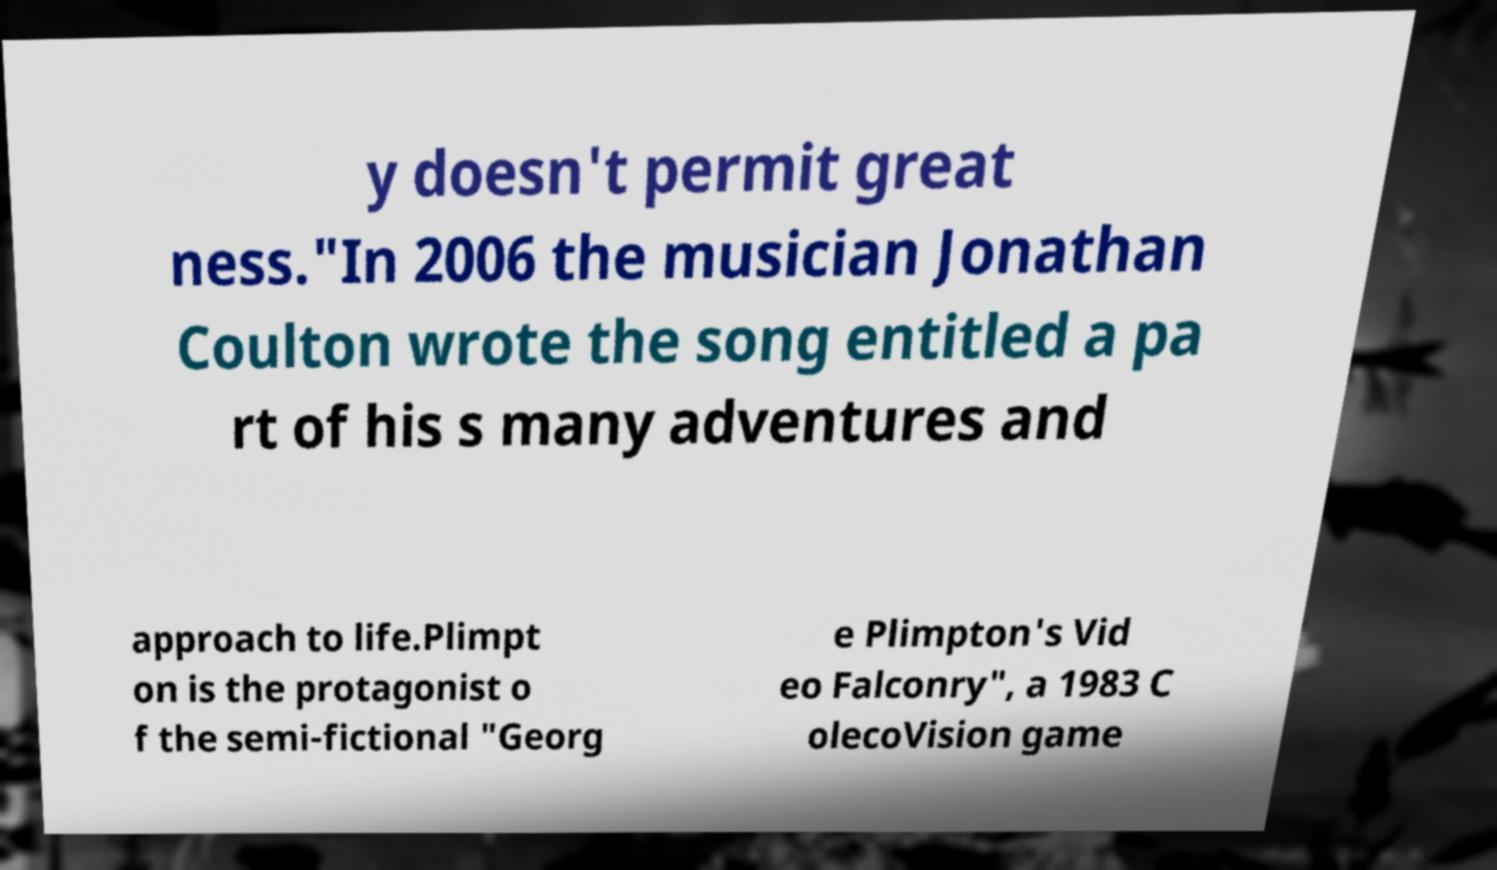Please identify and transcribe the text found in this image. y doesn't permit great ness."In 2006 the musician Jonathan Coulton wrote the song entitled a pa rt of his s many adventures and approach to life.Plimpt on is the protagonist o f the semi-fictional "Georg e Plimpton's Vid eo Falconry", a 1983 C olecoVision game 